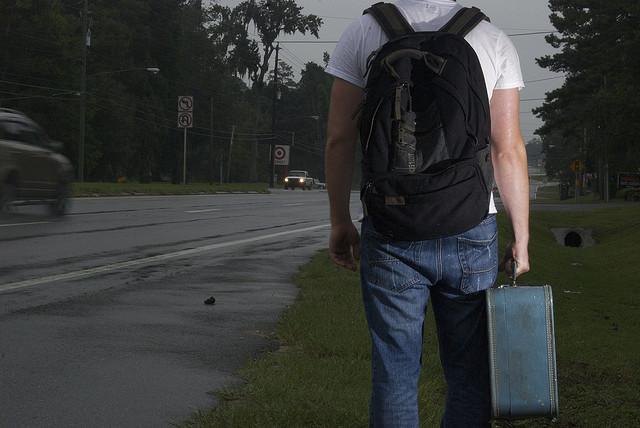What is the boy with black shirt holding?
Quick response, please. Suitcase. Is it raining?
Quick response, please. No. Where is the backpack?
Give a very brief answer. On his back. Is he dressed safely for night?
Write a very short answer. No. Is any part of this picture darker than others?
Answer briefly. Yes. What object is the man holding with his right arm?
Be succinct. Suitcase. 